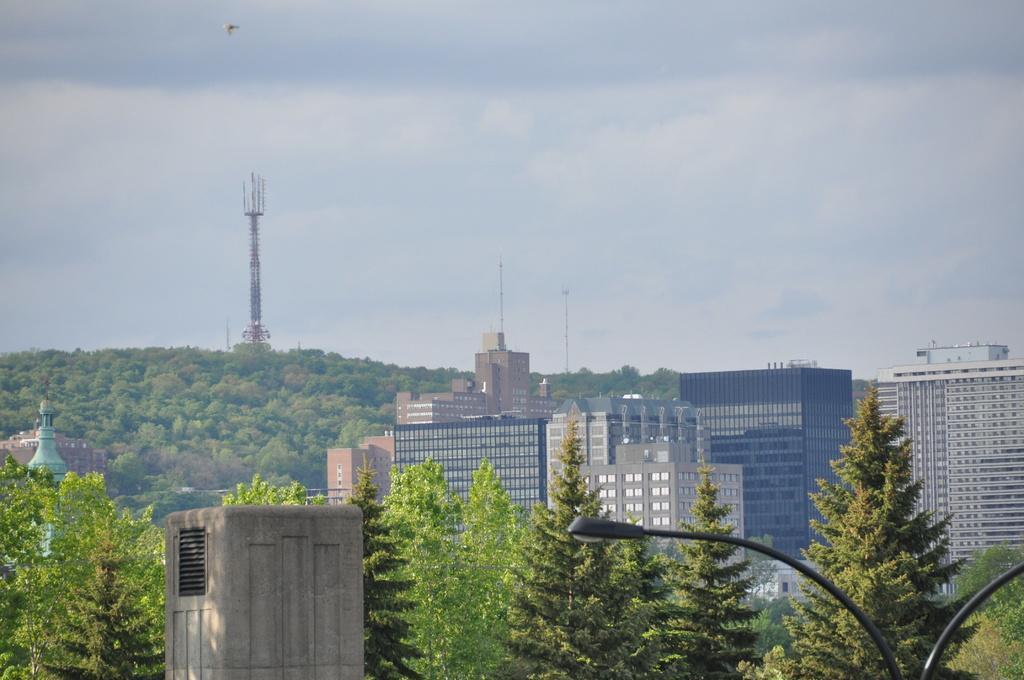Please provide a concise description of this image. In this image we can see that there are so many buildings in the middle. In the background it seems like a hill on which there is a tower. On the right side bottom there are lamp poles. In the middle there is a pillar. Beside the pillar there are trees. At the top there is the sky. 